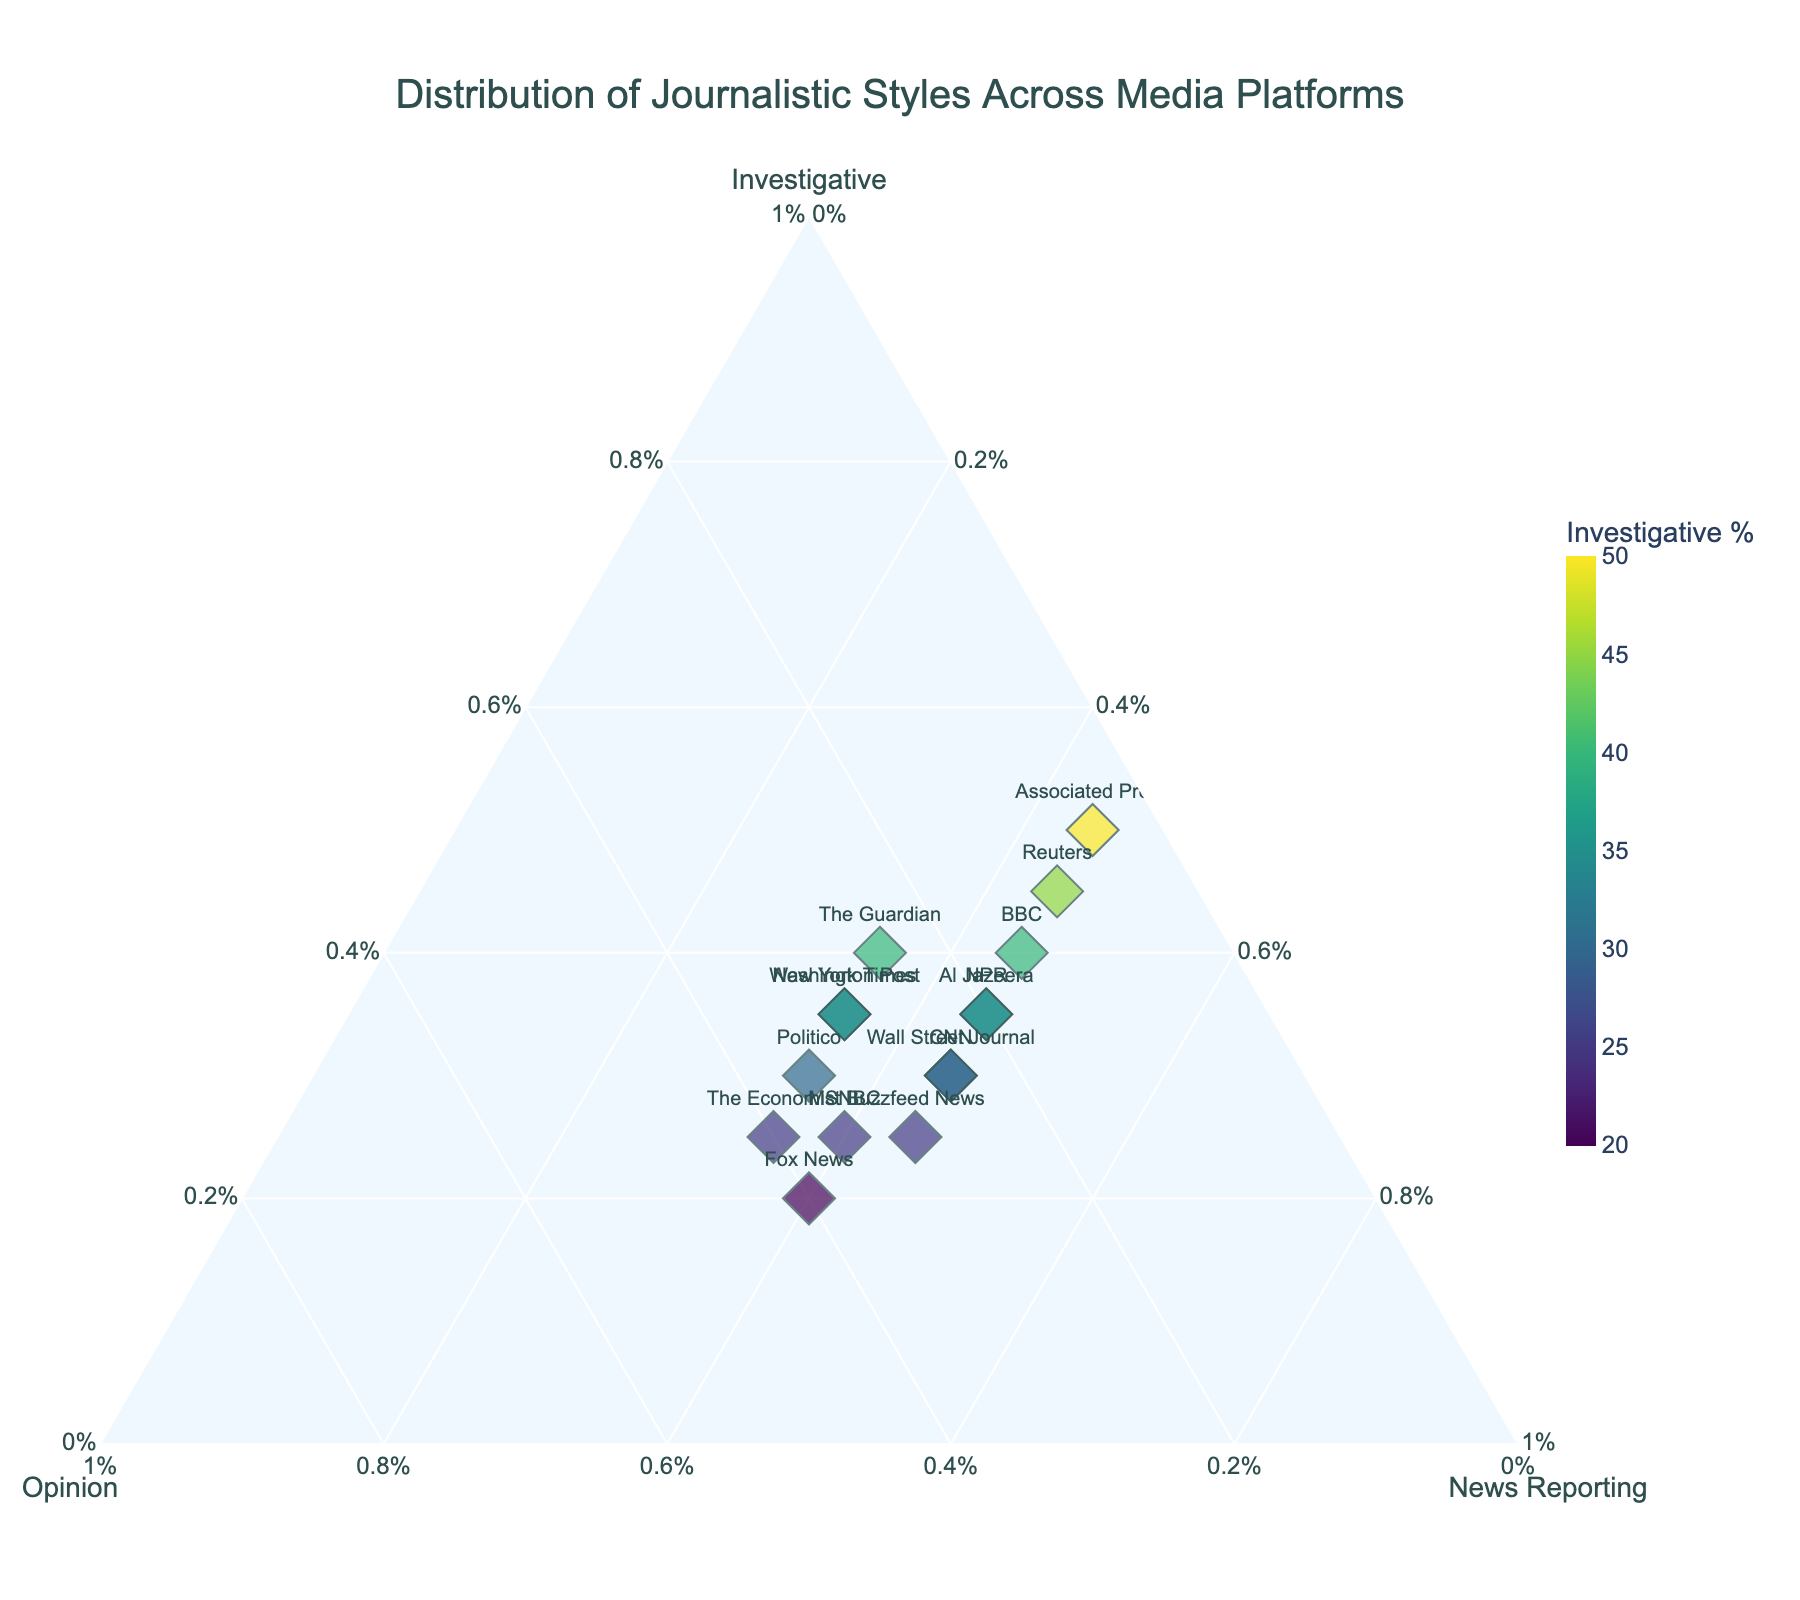What is the title of the figure? The title is displayed at the top of the figure and it summarizes the main topic of the plot.
Answer: Distribution of Journalistic Styles Across Media Platforms Which media platform has the highest Investigative percentage? Look for the point with the highest value along the Investigative axis (a-axis).
Answer: Associated Press Which media platform has the second-lowest Opinion percentage? Find the values for the Opinion axis (b-axis) for each media platform, then identify the second-lowest percentage.
Answer: Reuters What is the most common percentage for News Reporting across all media platforms? Identify the most frequently occurring value along the News Reporting axis (c-axis).
Answer: 45% Which media platforms show an equal percentage of Investigative and Opinion styles? Locate the points where the values for Investigative and Opinion are equal. This involves examining each marker.
Answer: Politico, Washington Post, New York Times How does the percentage of News Reporting for Fox News compare to that of The Guardian? Identify the values for News Reporting for both Fox News and The Guardian and compare them.
Answer: Both have 40% Which media platforms are positioned closest to the corner of the plot representing high News Reporting and low Opinion? Identify the platforms closest to the vertex of the triangle corresponding to high News Reporting and low Opinion.
Answer: Reuters, Associated Press What is the sum of the percentages of Investigative and Opinion styles for The Economist? Add the percentages of Investigative and Opinion styles for The Economist.
Answer: 65% Compare the size of the markers for BBC and NPR. Which one is larger? The size of the markers is based on the sum of the three journalistic styles. Locate and compare the marker sizes.
Answer: Both are equal Which media platform is represented by the marker closest to the center of the ternary plot? Identify the marker positioned nearest to the center of the triangle. This involves assessing the markers' proximity to the center.
Answer: Politico What is the distribution pattern among CNN, Fox News, and MSNBC in terms of Opinion percentage? Compare the percentages for Opinion among CNN, Fox News, and MSNBC.
Answer: CNN: 25%, Fox News: 40%, MSNBC: 35% 